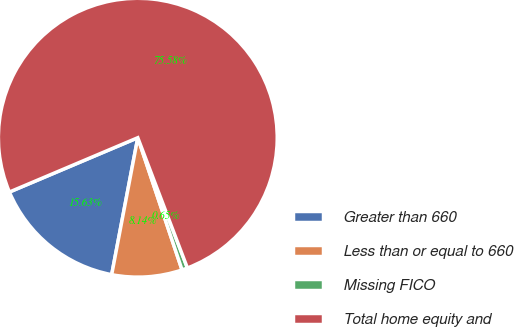Convert chart. <chart><loc_0><loc_0><loc_500><loc_500><pie_chart><fcel>Greater than 660<fcel>Less than or equal to 660<fcel>Missing FICO<fcel>Total home equity and<nl><fcel>15.63%<fcel>8.14%<fcel>0.65%<fcel>75.58%<nl></chart> 